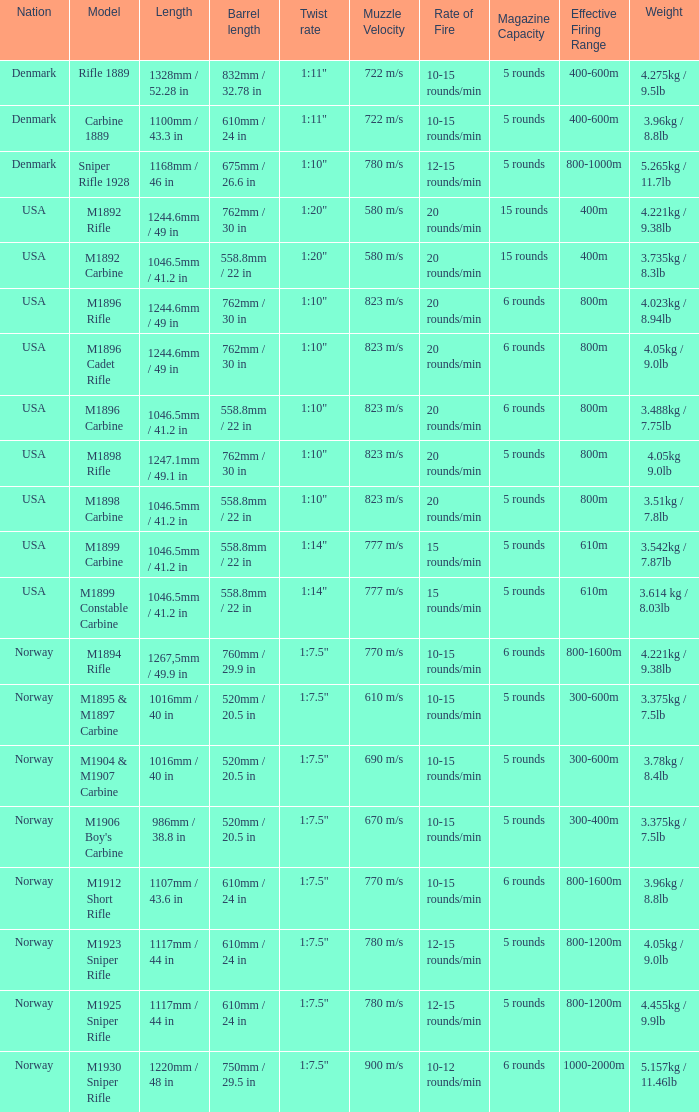What is Weight, when Length is 1168mm / 46 in? 5.265kg / 11.7lb. 